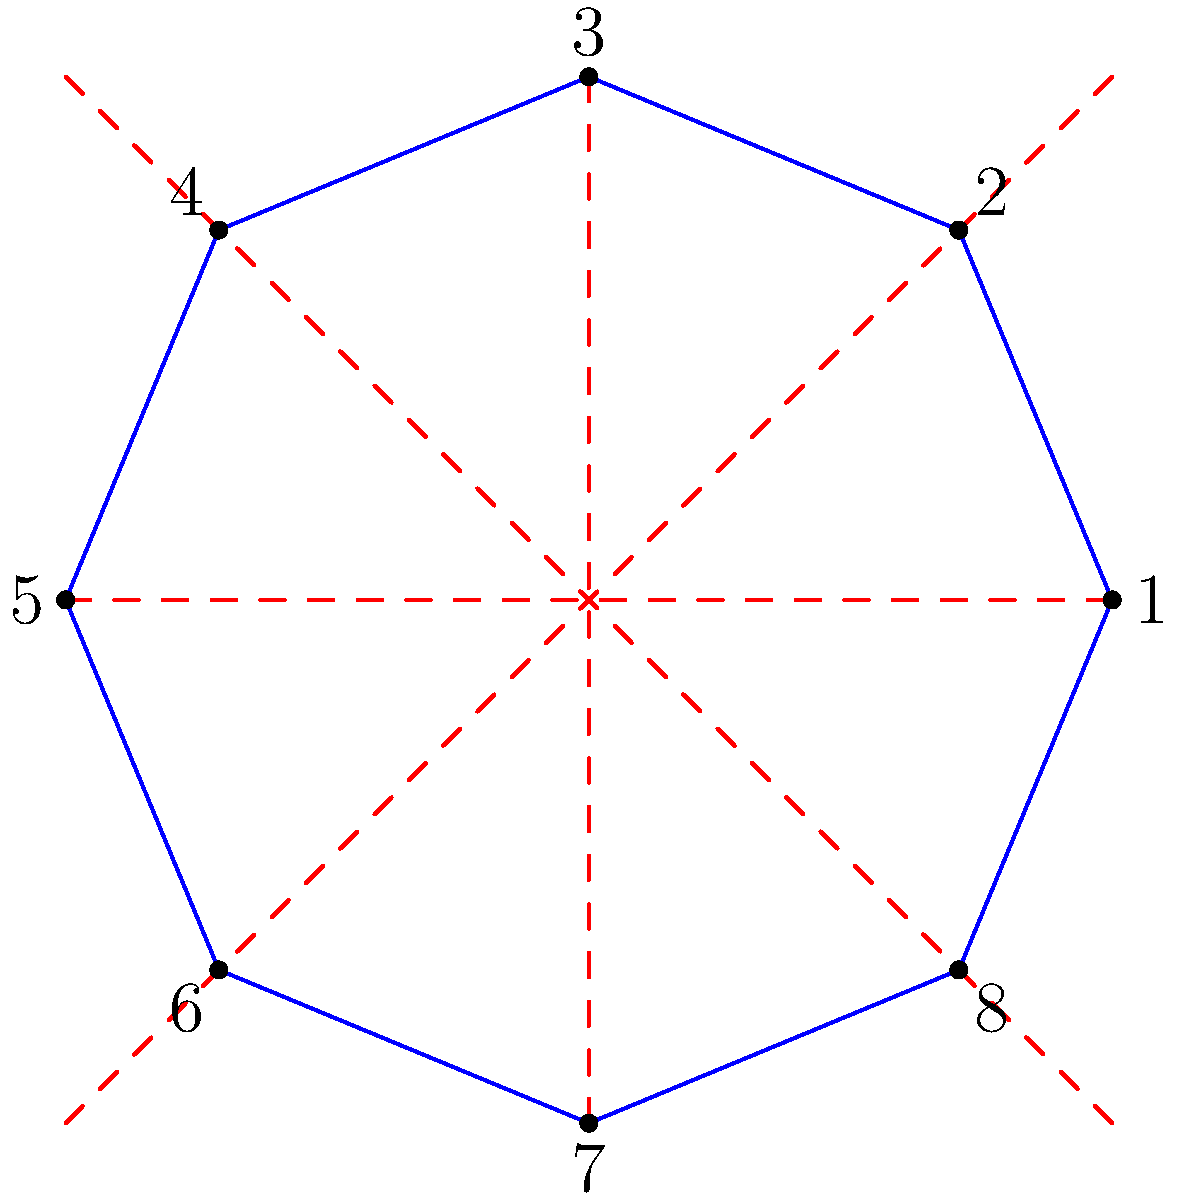In the fantasy novel "The Rune Codex," magical sigils are often represented as octagonal symbols. Consider the octagonal rune shown above, where each vertex represents a different magical element. How many symmetries does this rune possess according to the properties of the dihedral group $D_8$? Explain the significance of this number in terms of the rune's magical properties. To answer this question, we need to understand the properties of the dihedral group $D_8$ and how they relate to the symmetries of an octagon:

1. The dihedral group $D_8$ describes the symmetries of a regular octagon.

2. The order of $D_8$ is given by the formula $|D_n| = 2n$, where $n$ is the number of sides. In this case, $|D_8| = 2 \cdot 8 = 16$.

3. These 16 symmetries can be broken down into two types:
   a) 8 rotational symmetries (including the identity rotation)
   b) 8 reflectional symmetries

4. Rotational symmetries:
   - Identity rotation (0°)
   - Rotations by 45°, 90°, 135°, 180°, 225°, 270°, and 315°

5. Reflectional symmetries:
   - 4 reflections across the diagonals
   - 4 reflections across the lines connecting midpoints of opposite sides

6. In the context of the magical rune:
   - Each rotational symmetry could represent a different magical incantation or spell activation sequence.
   - Each reflectional symmetry could represent a way to balance or counteract opposing elemental forces.

7. The total number of symmetries (16) is significant because:
   - It allows for a wide variety of magical combinations and interactions between the 8 elements.
   - The balance between rotational and reflectional symmetries (8 each) suggests a fundamental equilibrium in the rune's magical properties.
   - The number 16 itself might have mystical significance in the novel's magical system, possibly relating to cycles or harmonies in the magical world.
Answer: 16 symmetries: 8 rotational and 8 reflectional, representing diverse magical combinations and elemental balance. 